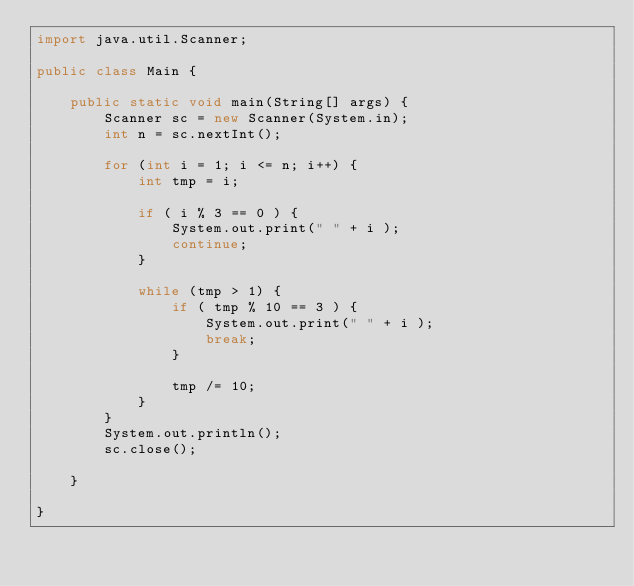Convert code to text. <code><loc_0><loc_0><loc_500><loc_500><_Java_>import java.util.Scanner;

public class Main {

	public static void main(String[] args) {
		Scanner sc = new Scanner(System.in);
		int n = sc.nextInt();

		for (int i = 1; i <= n; i++) {
			int tmp = i;

			if ( i % 3 == 0 ) {
				System.out.print(" " + i );
				continue;
			}

			while (tmp > 1) {
				if ( tmp % 10 == 3 ) {
					System.out.print(" " + i );
					break;
				}

				tmp /= 10;
			}
		}
		System.out.println();
		sc.close();

	}

}

</code> 